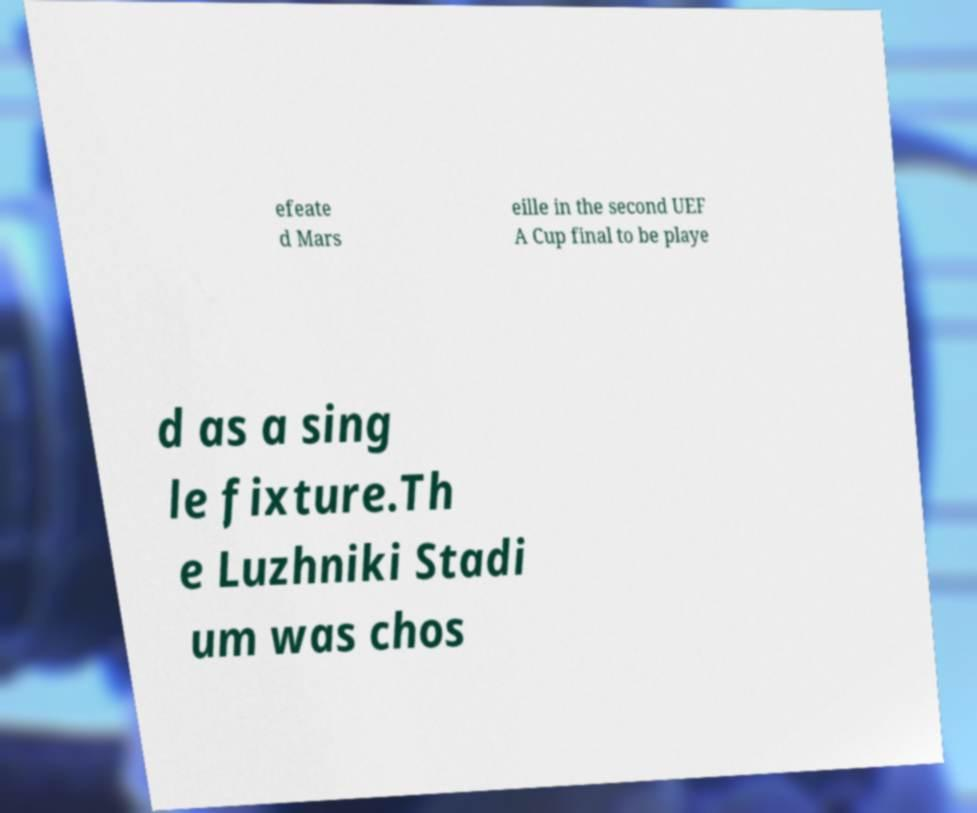What messages or text are displayed in this image? I need them in a readable, typed format. efeate d Mars eille in the second UEF A Cup final to be playe d as a sing le fixture.Th e Luzhniki Stadi um was chos 